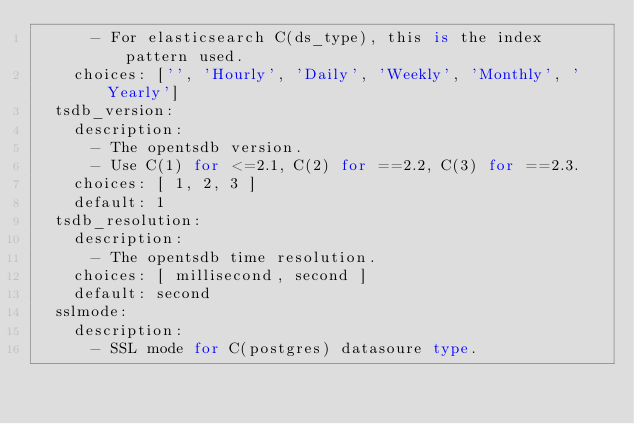Convert code to text. <code><loc_0><loc_0><loc_500><loc_500><_Python_>      - For elasticsearch C(ds_type), this is the index pattern used.
    choices: ['', 'Hourly', 'Daily', 'Weekly', 'Monthly', 'Yearly']
  tsdb_version:
    description:
      - The opentsdb version.
      - Use C(1) for <=2.1, C(2) for ==2.2, C(3) for ==2.3.
    choices: [ 1, 2, 3 ]
    default: 1
  tsdb_resolution:
    description:
      - The opentsdb time resolution.
    choices: [ millisecond, second ]
    default: second
  sslmode:
    description:
      - SSL mode for C(postgres) datasoure type.</code> 